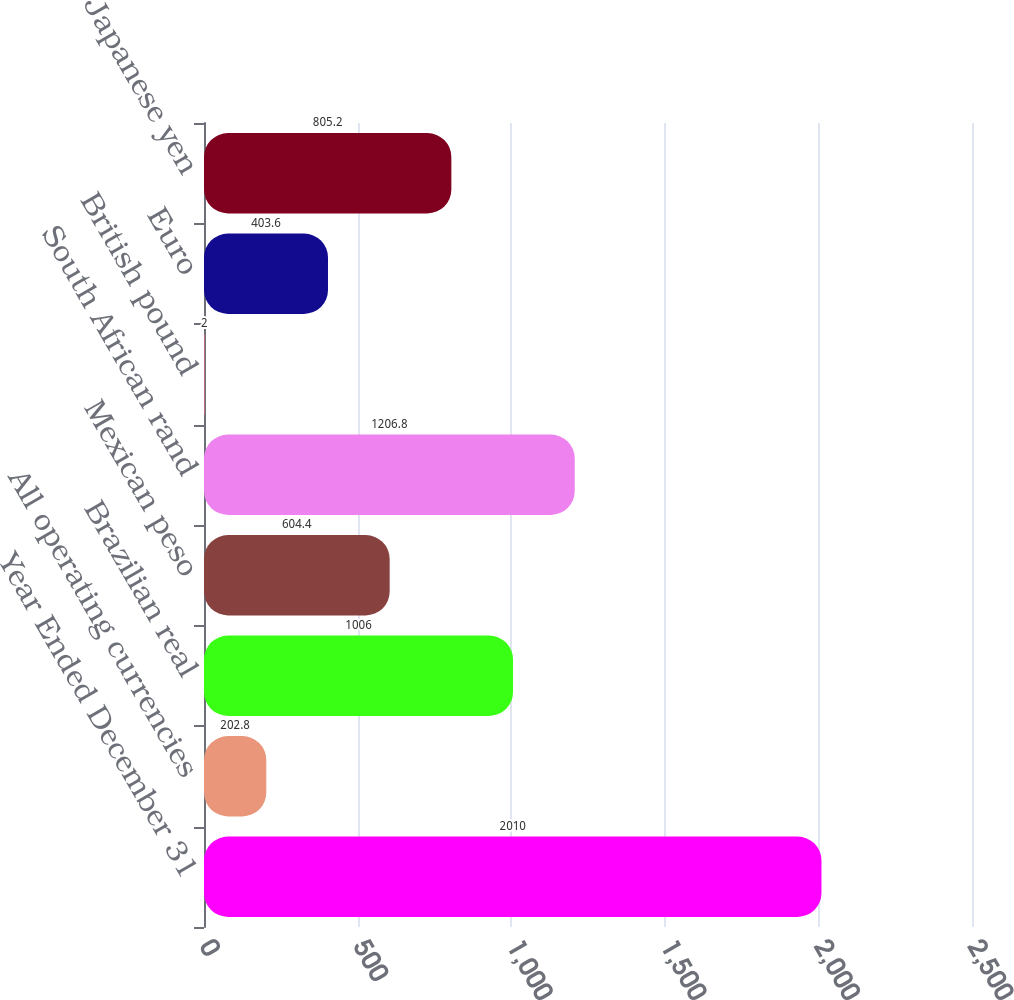Convert chart. <chart><loc_0><loc_0><loc_500><loc_500><bar_chart><fcel>Year Ended December 31<fcel>All operating currencies<fcel>Brazilian real<fcel>Mexican peso<fcel>South African rand<fcel>British pound<fcel>Euro<fcel>Japanese yen<nl><fcel>2010<fcel>202.8<fcel>1006<fcel>604.4<fcel>1206.8<fcel>2<fcel>403.6<fcel>805.2<nl></chart> 